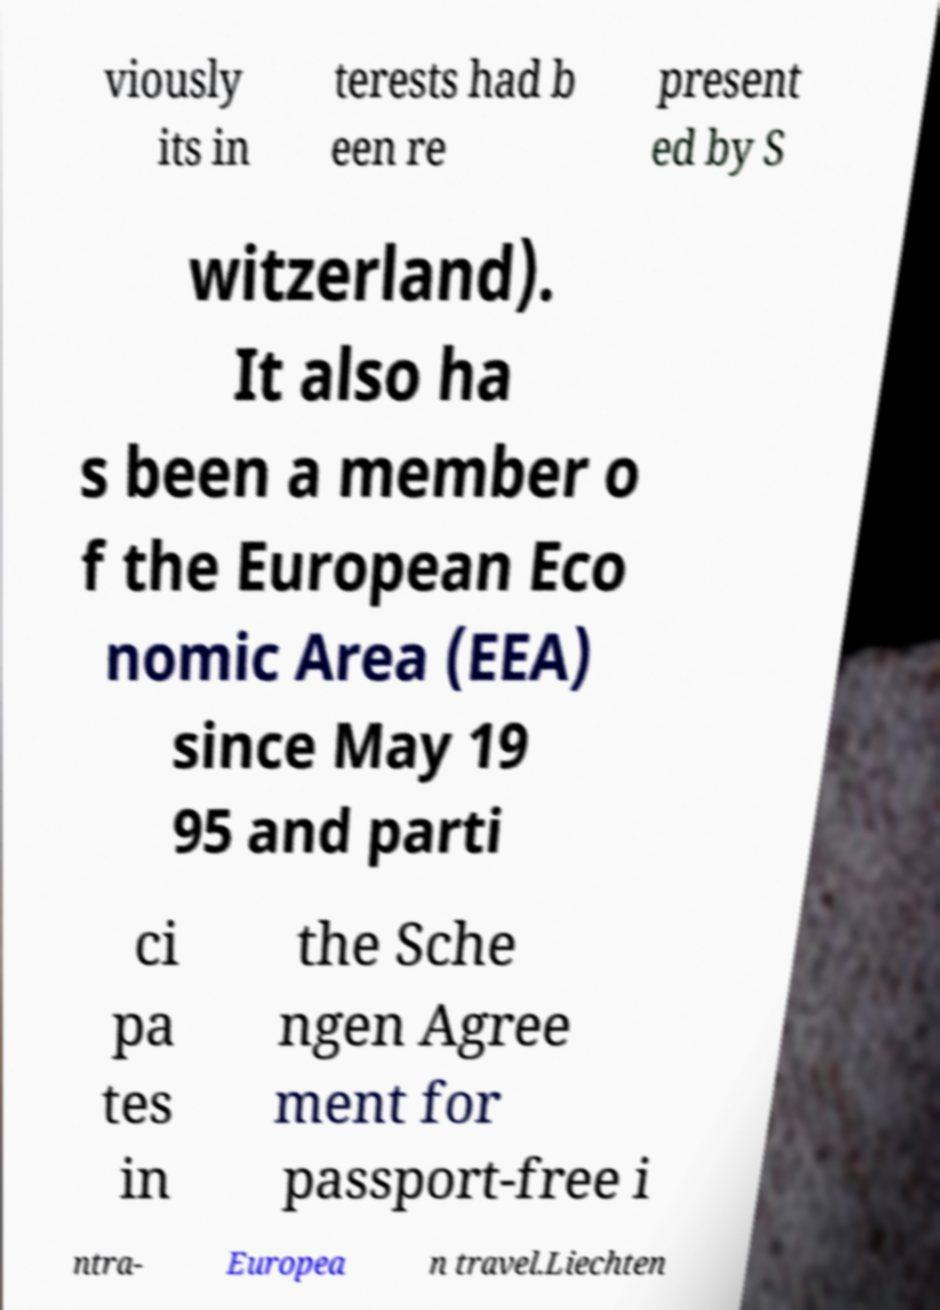Can you accurately transcribe the text from the provided image for me? viously its in terests had b een re present ed by S witzerland). It also ha s been a member o f the European Eco nomic Area (EEA) since May 19 95 and parti ci pa tes in the Sche ngen Agree ment for passport-free i ntra- Europea n travel.Liechten 